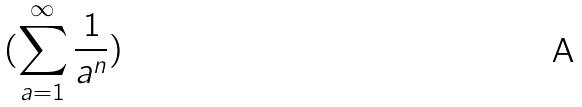Convert formula to latex. <formula><loc_0><loc_0><loc_500><loc_500>( \sum _ { a = 1 } ^ { \infty } \frac { 1 } { a ^ { n } } )</formula> 